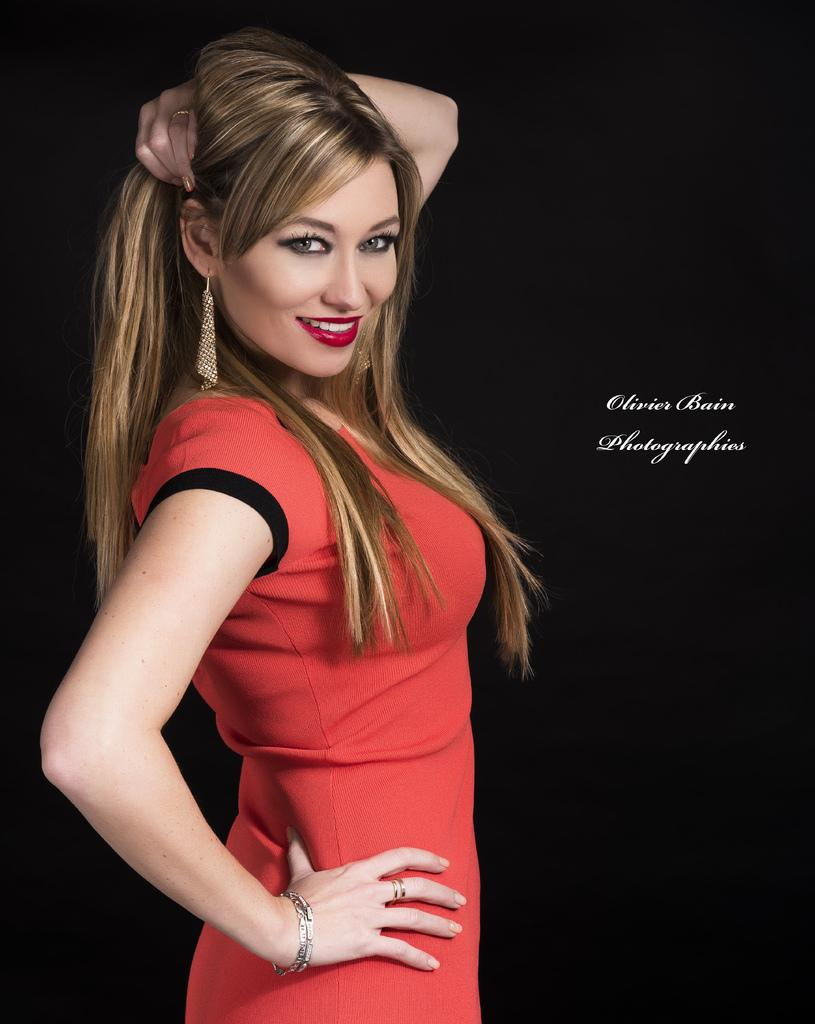Who is present in the image? There is a lady in the image. What is the lady doing in the image? The lady is smiling in the image. What else can be seen in the image besides the lady? There is some text in the image. What type of soup is the lady eating in the image? There is no soup present in the image; the lady is simply smiling. How many times does the lady sneeze in the image? The lady does not sneeze in the image; she is only smiling. 